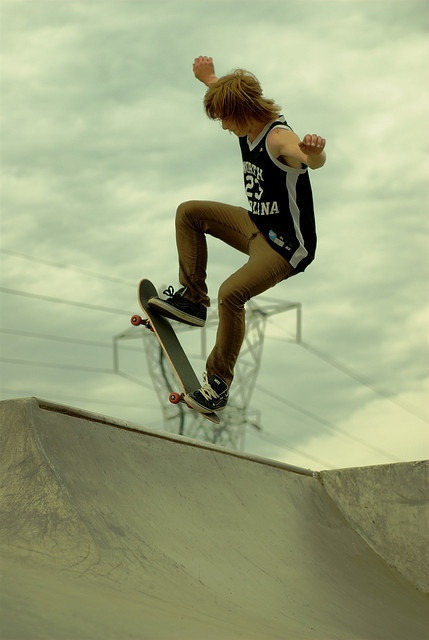Describe the objects in this image and their specific colors. I can see people in beige, black, olive, maroon, and gray tones and skateboard in beige, black, darkgreen, and tan tones in this image. 